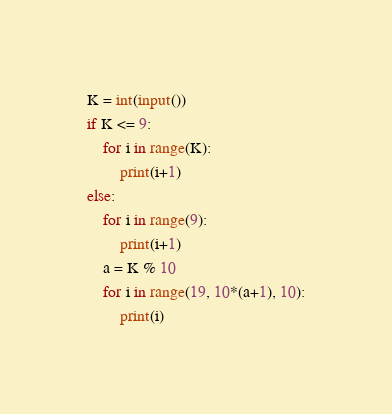<code> <loc_0><loc_0><loc_500><loc_500><_Python_>K = int(input())
if K <= 9:
    for i in range(K):
        print(i+1)
else:
    for i in range(9):
        print(i+1)
    a = K % 10
    for i in range(19, 10*(a+1), 10):
        print(i)</code> 